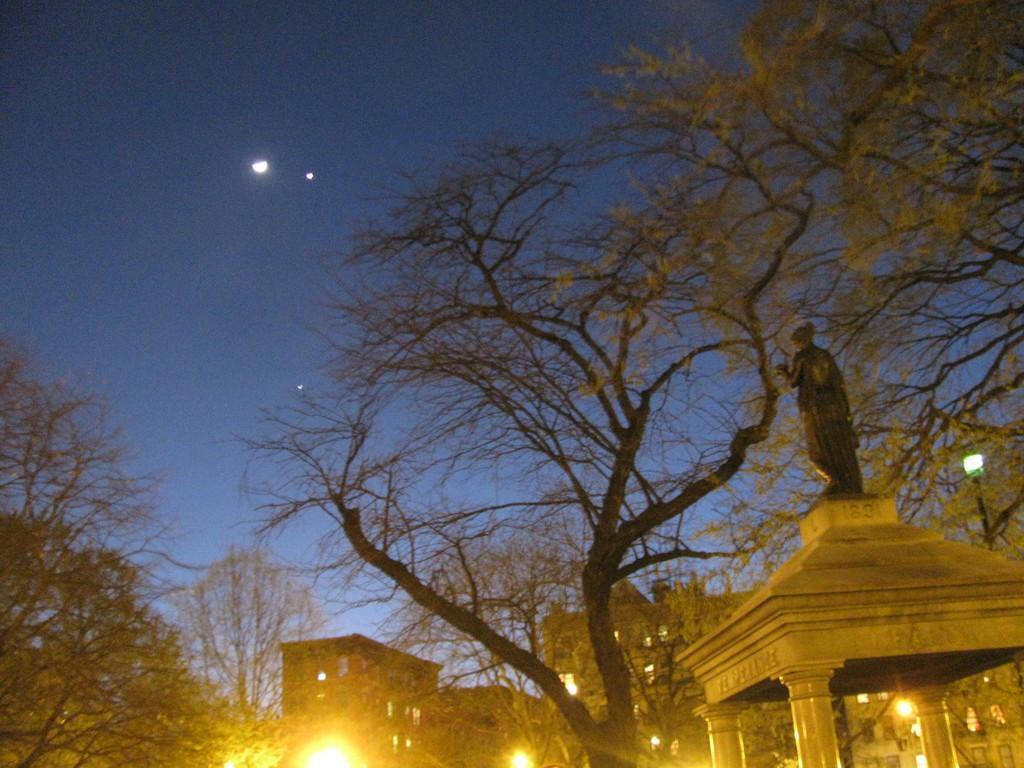Can you describe this image briefly? In the foreground of the picture we can see trees, sculpture and a small construction. In the background there are street lights and buildings. At the top we can see stars and moon in the sky. 